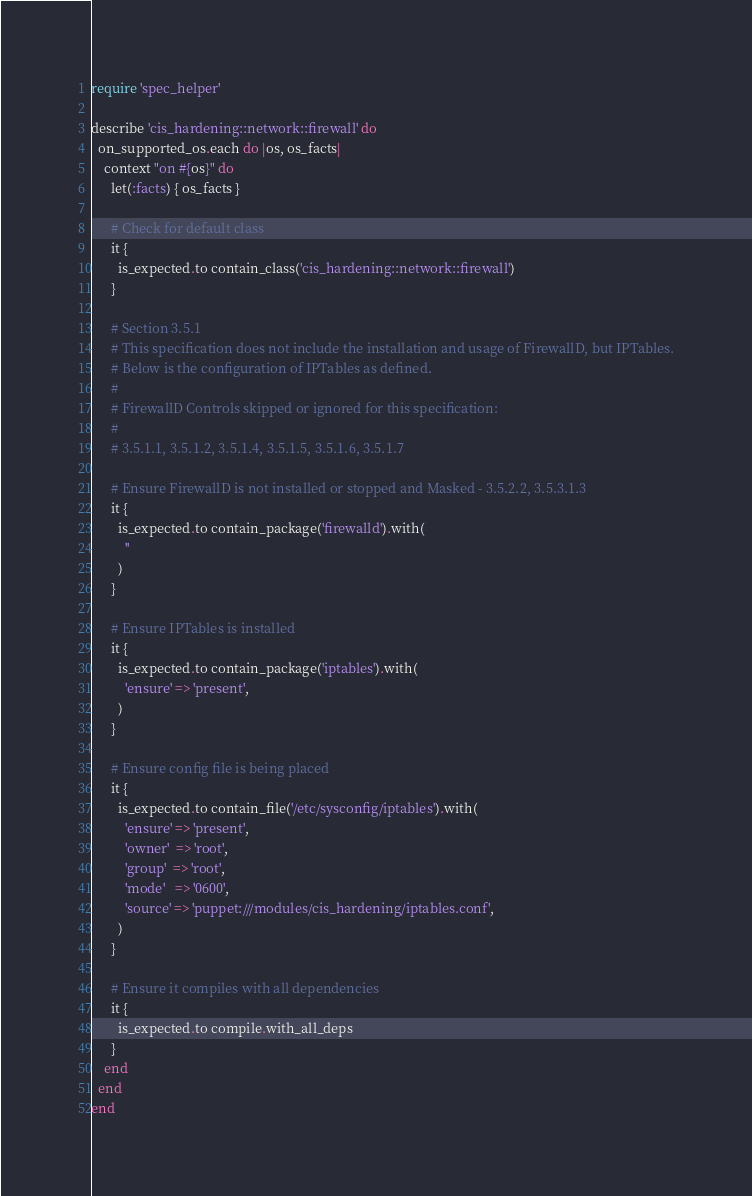<code> <loc_0><loc_0><loc_500><loc_500><_Ruby_>require 'spec_helper'

describe 'cis_hardening::network::firewall' do
  on_supported_os.each do |os, os_facts|
    context "on #{os}" do
      let(:facts) { os_facts }

      # Check for default class
      it {
        is_expected.to contain_class('cis_hardening::network::firewall')
      }

      # Section 3.5.1
      # This specification does not include the installation and usage of FirewallD, but IPTables.
      # Below is the configuration of IPTables as defined.
      #
      # FirewallD Controls skipped or ignored for this specification:
      #
      # 3.5.1.1, 3.5.1.2, 3.5.1.4, 3.5.1.5, 3.5.1.6, 3.5.1.7

      # Ensure FirewallD is not installed or stopped and Masked - 3.5.2.2, 3.5.3.1.3
      it {
        is_expected.to contain_package('firewalld').with(
          ''
        )
      }

      # Ensure IPTables is installed
      it {
        is_expected.to contain_package('iptables').with(
          'ensure' => 'present',
        )
      }

      # Ensure config file is being placed
      it {
        is_expected.to contain_file('/etc/sysconfig/iptables').with(
          'ensure' => 'present',
          'owner'  => 'root',
          'group'  => 'root',
          'mode'   => '0600',
          'source' => 'puppet:///modules/cis_hardening/iptables.conf',
        )
      }

      # Ensure it compiles with all dependencies
      it {
        is_expected.to compile.with_all_deps
      }
    end
  end
end
</code> 